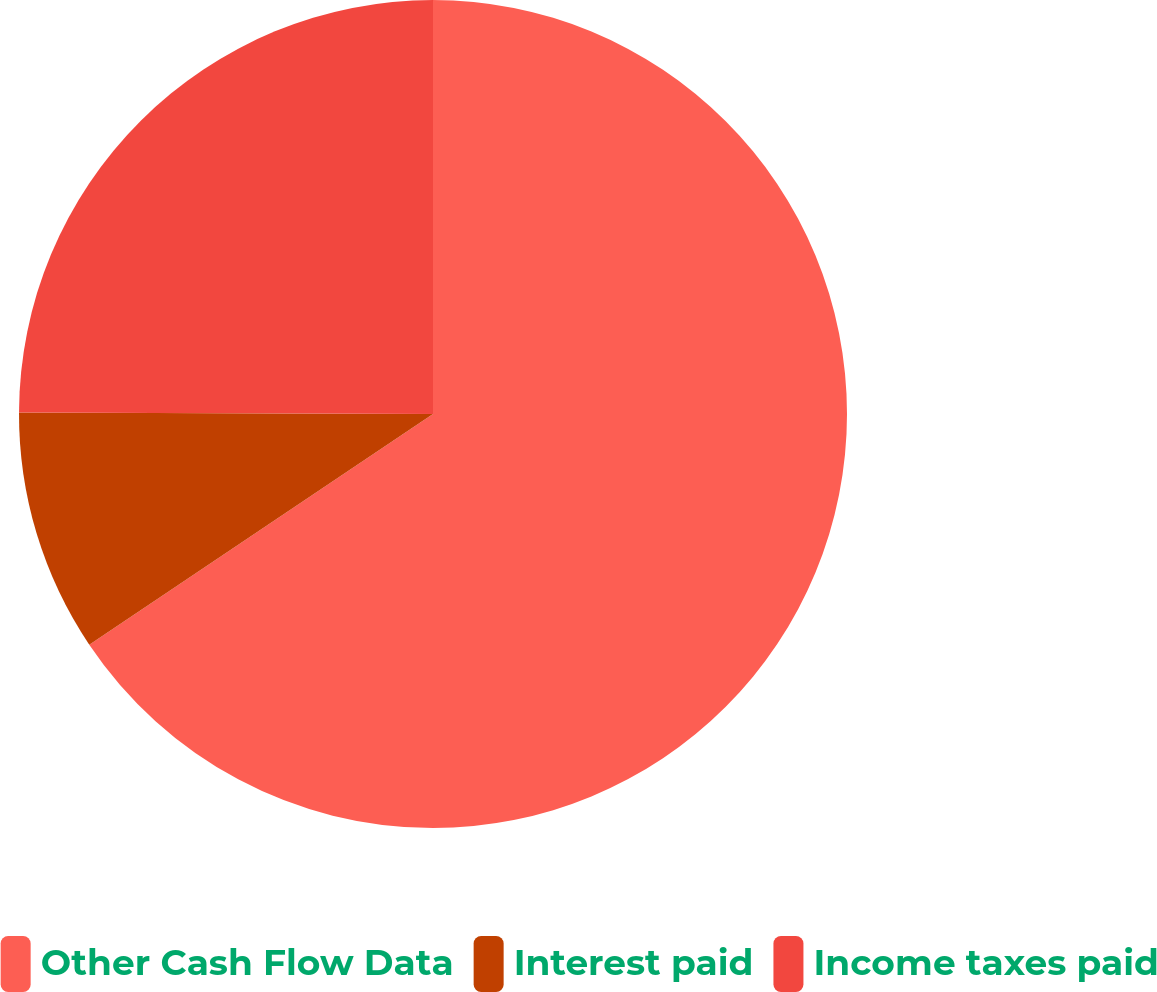Convert chart to OTSL. <chart><loc_0><loc_0><loc_500><loc_500><pie_chart><fcel>Other Cash Flow Data<fcel>Interest paid<fcel>Income taxes paid<nl><fcel>65.59%<fcel>9.47%<fcel>24.94%<nl></chart> 